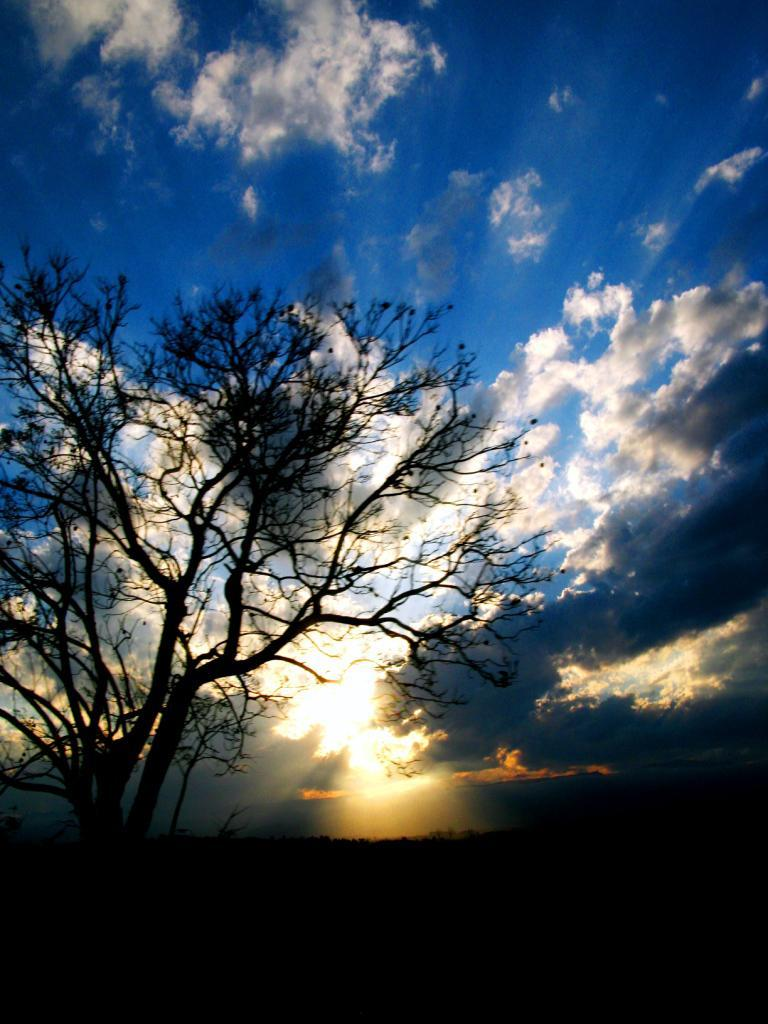What type of plant can be seen in the image? There is a tree in the image. What can be seen in the background of the image? The sky is visible in the background of the image. How many cats are sitting on the branches of the tree in the image? There are no cats present in the image; it only features a tree and the sky in the background. 